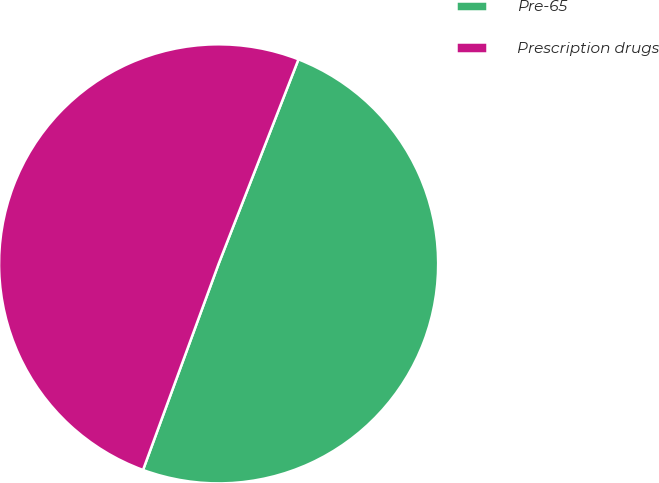Convert chart. <chart><loc_0><loc_0><loc_500><loc_500><pie_chart><fcel>Pre-65<fcel>Prescription drugs<nl><fcel>49.67%<fcel>50.33%<nl></chart> 